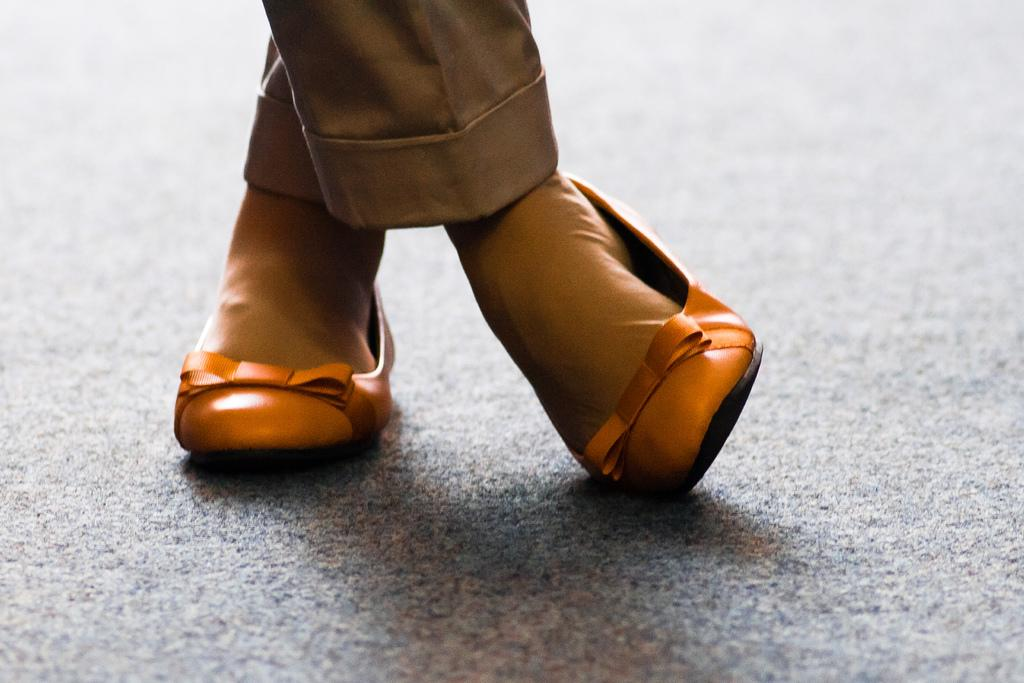Who or what is the main subject in the image? There is a person in the image. What is the person wearing in the image? The person is wearing a brown color dress. Are there any footwear visible in the image? Yes, the person is wearing shoes. What is the color of the surface the person is standing on? The person is standing on an ash color surface. What type of bath can be seen in the image? There is no bath present in the image; it features a person wearing a brown dress and standing on an ash color surface. 